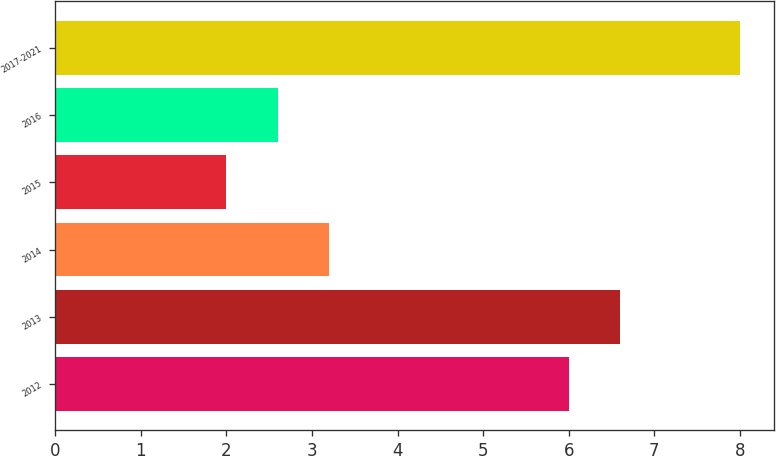Convert chart to OTSL. <chart><loc_0><loc_0><loc_500><loc_500><bar_chart><fcel>2012<fcel>2013<fcel>2014<fcel>2015<fcel>2016<fcel>2017-2021<nl><fcel>6<fcel>6.6<fcel>3.2<fcel>2<fcel>2.6<fcel>8<nl></chart> 